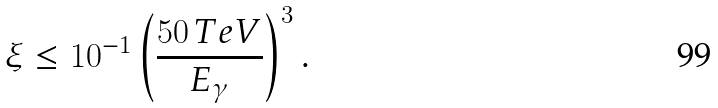<formula> <loc_0><loc_0><loc_500><loc_500>\xi \leq 1 0 ^ { - 1 } \left ( \frac { 5 0 \, T e V } { E _ { \gamma } } \right ) ^ { 3 } .</formula> 